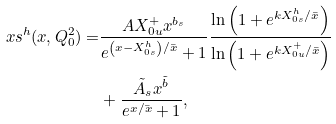Convert formula to latex. <formula><loc_0><loc_0><loc_500><loc_500>x s ^ { h } ( x , Q _ { 0 } ^ { 2 } ) = & \frac { A X ^ { + } _ { 0 u } x ^ { b _ { s } } } { e ^ { \left ( x - X ^ { h } _ { 0 s } \right ) / \bar { x } } + 1 } \frac { \ln \left ( 1 + e ^ { k X _ { 0 s } ^ { h } / \bar { x } } \right ) } { \ln \left ( 1 + e ^ { k X _ { 0 u } ^ { + } / \bar { x } } \right ) } \\ & + \frac { \tilde { A } _ { s } x ^ { \tilde { b } } } { e ^ { x / \bar { x } } + 1 } ,</formula> 